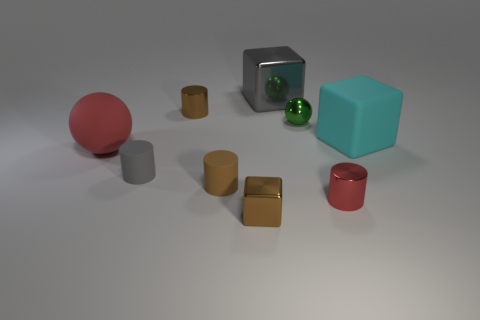Subtract all gray metal blocks. How many blocks are left? 2 Add 1 tiny brown cylinders. How many objects exist? 10 Subtract all brown cylinders. How many cylinders are left? 2 Subtract all purple blocks. How many brown cylinders are left? 2 Add 1 matte things. How many matte things exist? 5 Subtract 1 gray blocks. How many objects are left? 8 Subtract all blocks. How many objects are left? 6 Subtract all brown cubes. Subtract all green spheres. How many cubes are left? 2 Subtract all matte things. Subtract all large yellow rubber balls. How many objects are left? 5 Add 1 big gray shiny things. How many big gray shiny things are left? 2 